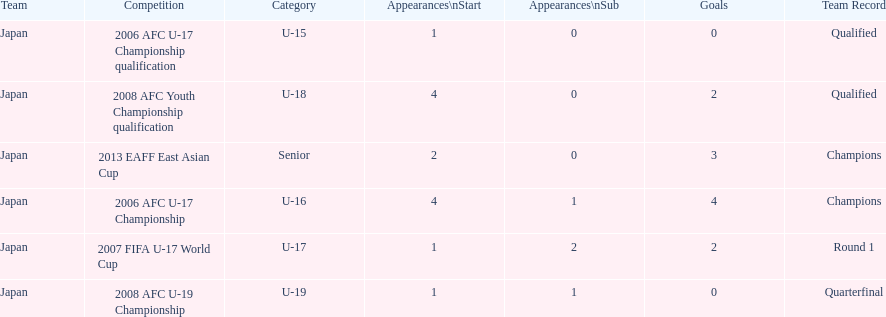In which two competitions did japan lack goals? 2006 AFC U-17 Championship qualification, 2008 AFC U-19 Championship. 